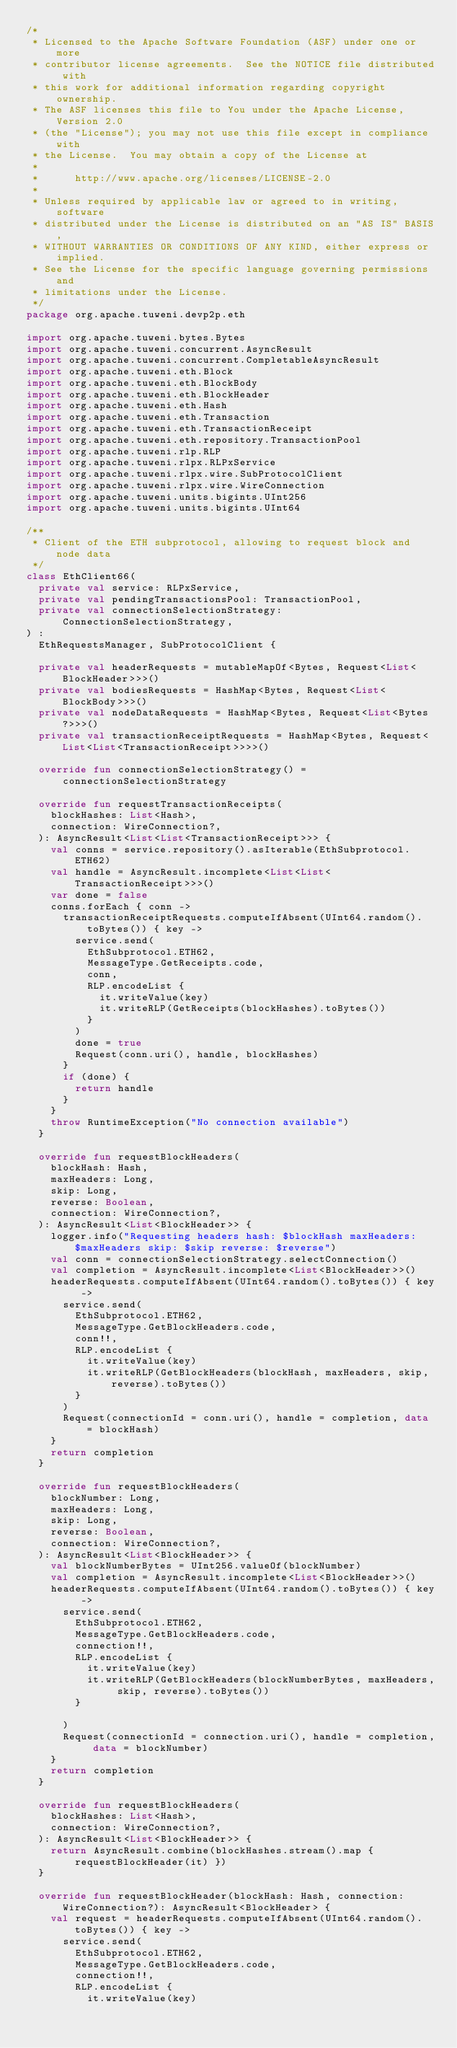Convert code to text. <code><loc_0><loc_0><loc_500><loc_500><_Kotlin_>/*
 * Licensed to the Apache Software Foundation (ASF) under one or more
 * contributor license agreements.  See the NOTICE file distributed with
 * this work for additional information regarding copyright ownership.
 * The ASF licenses this file to You under the Apache License, Version 2.0
 * (the "License"); you may not use this file except in compliance with
 * the License.  You may obtain a copy of the License at
 *
 *      http://www.apache.org/licenses/LICENSE-2.0
 *
 * Unless required by applicable law or agreed to in writing, software
 * distributed under the License is distributed on an "AS IS" BASIS,
 * WITHOUT WARRANTIES OR CONDITIONS OF ANY KIND, either express or implied.
 * See the License for the specific language governing permissions and
 * limitations under the License.
 */
package org.apache.tuweni.devp2p.eth

import org.apache.tuweni.bytes.Bytes
import org.apache.tuweni.concurrent.AsyncResult
import org.apache.tuweni.concurrent.CompletableAsyncResult
import org.apache.tuweni.eth.Block
import org.apache.tuweni.eth.BlockBody
import org.apache.tuweni.eth.BlockHeader
import org.apache.tuweni.eth.Hash
import org.apache.tuweni.eth.Transaction
import org.apache.tuweni.eth.TransactionReceipt
import org.apache.tuweni.eth.repository.TransactionPool
import org.apache.tuweni.rlp.RLP
import org.apache.tuweni.rlpx.RLPxService
import org.apache.tuweni.rlpx.wire.SubProtocolClient
import org.apache.tuweni.rlpx.wire.WireConnection
import org.apache.tuweni.units.bigints.UInt256
import org.apache.tuweni.units.bigints.UInt64

/**
 * Client of the ETH subprotocol, allowing to request block and node data
 */
class EthClient66(
  private val service: RLPxService,
  private val pendingTransactionsPool: TransactionPool,
  private val connectionSelectionStrategy: ConnectionSelectionStrategy,
) :
  EthRequestsManager, SubProtocolClient {

  private val headerRequests = mutableMapOf<Bytes, Request<List<BlockHeader>>>()
  private val bodiesRequests = HashMap<Bytes, Request<List<BlockBody>>>()
  private val nodeDataRequests = HashMap<Bytes, Request<List<Bytes?>>>()
  private val transactionReceiptRequests = HashMap<Bytes, Request<List<List<TransactionReceipt>>>>()

  override fun connectionSelectionStrategy() = connectionSelectionStrategy

  override fun requestTransactionReceipts(
    blockHashes: List<Hash>,
    connection: WireConnection?,
  ): AsyncResult<List<List<TransactionReceipt>>> {
    val conns = service.repository().asIterable(EthSubprotocol.ETH62)
    val handle = AsyncResult.incomplete<List<List<TransactionReceipt>>>()
    var done = false
    conns.forEach { conn ->
      transactionReceiptRequests.computeIfAbsent(UInt64.random().toBytes()) { key ->
        service.send(
          EthSubprotocol.ETH62,
          MessageType.GetReceipts.code,
          conn,
          RLP.encodeList {
            it.writeValue(key)
            it.writeRLP(GetReceipts(blockHashes).toBytes())
          }
        )
        done = true
        Request(conn.uri(), handle, blockHashes)
      }
      if (done) {
        return handle
      }
    }
    throw RuntimeException("No connection available")
  }

  override fun requestBlockHeaders(
    blockHash: Hash,
    maxHeaders: Long,
    skip: Long,
    reverse: Boolean,
    connection: WireConnection?,
  ): AsyncResult<List<BlockHeader>> {
    logger.info("Requesting headers hash: $blockHash maxHeaders: $maxHeaders skip: $skip reverse: $reverse")
    val conn = connectionSelectionStrategy.selectConnection()
    val completion = AsyncResult.incomplete<List<BlockHeader>>()
    headerRequests.computeIfAbsent(UInt64.random().toBytes()) { key ->
      service.send(
        EthSubprotocol.ETH62,
        MessageType.GetBlockHeaders.code,
        conn!!,
        RLP.encodeList {
          it.writeValue(key)
          it.writeRLP(GetBlockHeaders(blockHash, maxHeaders, skip, reverse).toBytes())
        }
      )
      Request(connectionId = conn.uri(), handle = completion, data = blockHash)
    }
    return completion
  }

  override fun requestBlockHeaders(
    blockNumber: Long,
    maxHeaders: Long,
    skip: Long,
    reverse: Boolean,
    connection: WireConnection?,
  ): AsyncResult<List<BlockHeader>> {
    val blockNumberBytes = UInt256.valueOf(blockNumber)
    val completion = AsyncResult.incomplete<List<BlockHeader>>()
    headerRequests.computeIfAbsent(UInt64.random().toBytes()) { key ->
      service.send(
        EthSubprotocol.ETH62,
        MessageType.GetBlockHeaders.code,
        connection!!,
        RLP.encodeList {
          it.writeValue(key)
          it.writeRLP(GetBlockHeaders(blockNumberBytes, maxHeaders, skip, reverse).toBytes())
        }

      )
      Request(connectionId = connection.uri(), handle = completion, data = blockNumber)
    }
    return completion
  }

  override fun requestBlockHeaders(
    blockHashes: List<Hash>,
    connection: WireConnection?,
  ): AsyncResult<List<BlockHeader>> {
    return AsyncResult.combine(blockHashes.stream().map { requestBlockHeader(it) })
  }

  override fun requestBlockHeader(blockHash: Hash, connection: WireConnection?): AsyncResult<BlockHeader> {
    val request = headerRequests.computeIfAbsent(UInt64.random().toBytes()) { key ->
      service.send(
        EthSubprotocol.ETH62,
        MessageType.GetBlockHeaders.code,
        connection!!,
        RLP.encodeList {
          it.writeValue(key)</code> 